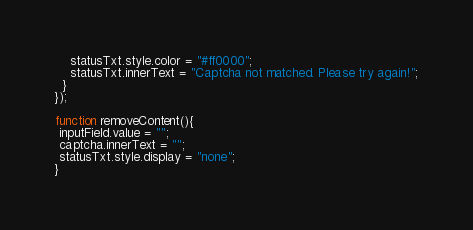<code> <loc_0><loc_0><loc_500><loc_500><_JavaScript_>    statusTxt.style.color = "#ff0000";
    statusTxt.innerText = "Captcha not matched. Please try again!";
  }
});

function removeContent(){
 inputField.value = "";
 captcha.innerText = "";
 statusTxt.style.display = "none";
}
</code> 